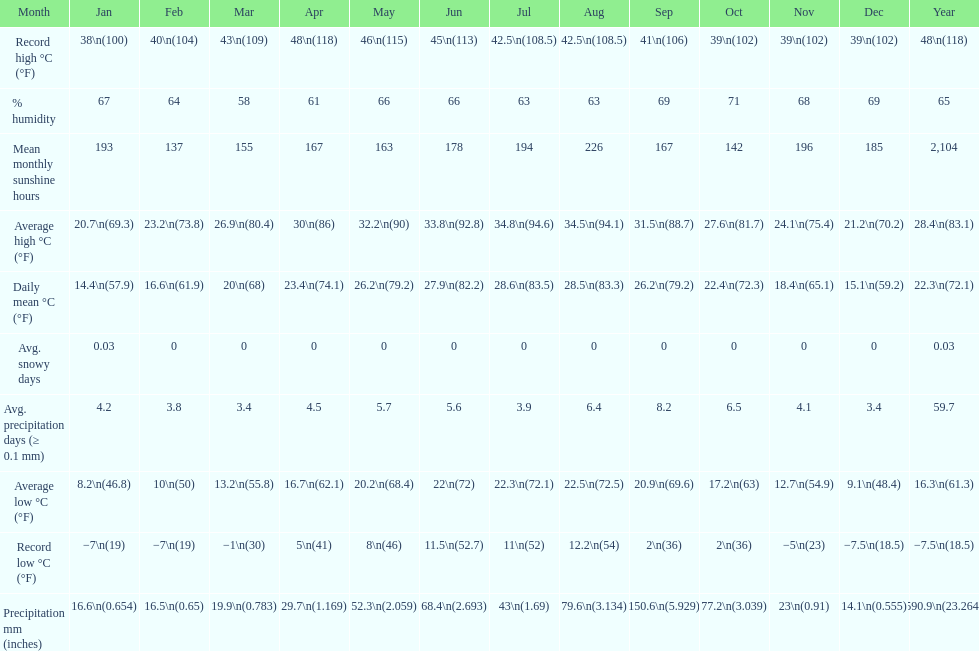Which month had the most sunny days? August. 